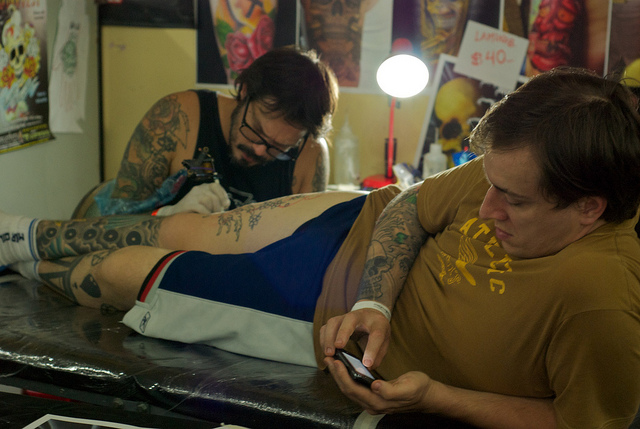Please provide the bounding box coordinate of the region this sentence describes: man getting tattooed. The bounding box capturing this scene where a man is being tattooed, including the tattoo artist in action, is defined by the coordinates [0.0, 0.27, 1.0, 0.83]. This encompasses the lower left portion of the image extending upwards to just beyond the middle, and spanning the full width, capturing both the client and the artist fully engaged in the tattooing process. 